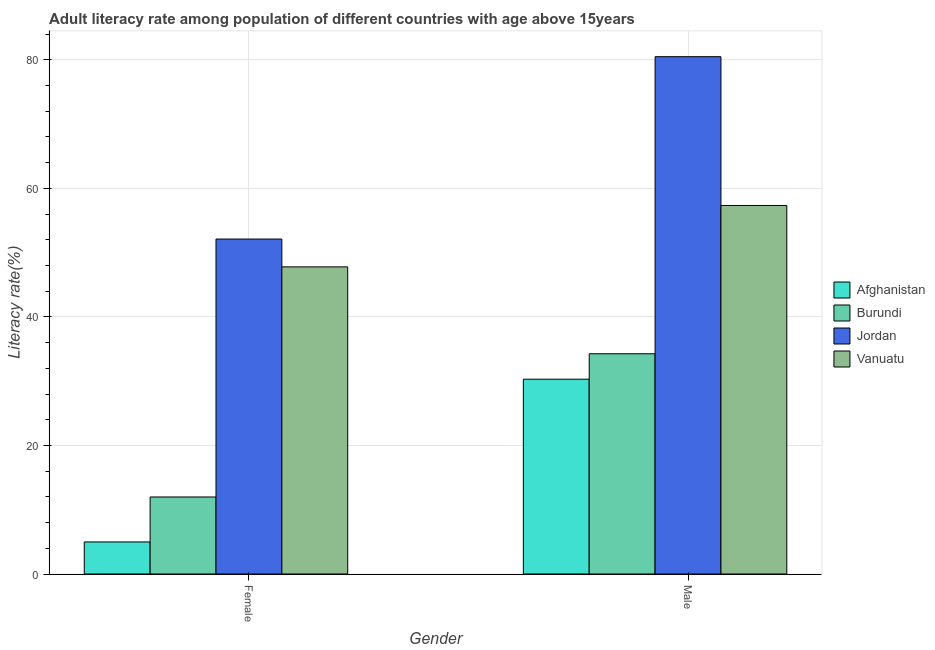How many different coloured bars are there?
Provide a short and direct response. 4. How many groups of bars are there?
Ensure brevity in your answer.  2. Are the number of bars per tick equal to the number of legend labels?
Give a very brief answer. Yes. What is the label of the 2nd group of bars from the left?
Make the answer very short. Male. What is the male adult literacy rate in Burundi?
Make the answer very short. 34.26. Across all countries, what is the maximum female adult literacy rate?
Give a very brief answer. 52.11. Across all countries, what is the minimum female adult literacy rate?
Make the answer very short. 4.99. In which country was the male adult literacy rate maximum?
Keep it short and to the point. Jordan. In which country was the female adult literacy rate minimum?
Offer a very short reply. Afghanistan. What is the total male adult literacy rate in the graph?
Make the answer very short. 202.39. What is the difference between the male adult literacy rate in Jordan and that in Afghanistan?
Provide a succinct answer. 50.17. What is the difference between the male adult literacy rate in Afghanistan and the female adult literacy rate in Vanuatu?
Make the answer very short. -17.47. What is the average male adult literacy rate per country?
Your answer should be compact. 50.6. What is the difference between the female adult literacy rate and male adult literacy rate in Afghanistan?
Provide a short and direct response. -25.32. What is the ratio of the male adult literacy rate in Jordan to that in Vanuatu?
Your response must be concise. 1.4. Is the female adult literacy rate in Jordan less than that in Afghanistan?
Give a very brief answer. No. What does the 2nd bar from the left in Female represents?
Provide a short and direct response. Burundi. What does the 1st bar from the right in Male represents?
Offer a very short reply. Vanuatu. How many bars are there?
Provide a short and direct response. 8. Are the values on the major ticks of Y-axis written in scientific E-notation?
Your answer should be very brief. No. Does the graph contain any zero values?
Provide a short and direct response. No. Does the graph contain grids?
Offer a very short reply. Yes. Where does the legend appear in the graph?
Give a very brief answer. Center right. How are the legend labels stacked?
Give a very brief answer. Vertical. What is the title of the graph?
Give a very brief answer. Adult literacy rate among population of different countries with age above 15years. What is the label or title of the X-axis?
Your response must be concise. Gender. What is the label or title of the Y-axis?
Provide a succinct answer. Literacy rate(%). What is the Literacy rate(%) in Afghanistan in Female?
Your response must be concise. 4.99. What is the Literacy rate(%) of Burundi in Female?
Your response must be concise. 11.98. What is the Literacy rate(%) in Jordan in Female?
Ensure brevity in your answer.  52.11. What is the Literacy rate(%) in Vanuatu in Female?
Your answer should be very brief. 47.78. What is the Literacy rate(%) in Afghanistan in Male?
Keep it short and to the point. 30.31. What is the Literacy rate(%) in Burundi in Male?
Provide a short and direct response. 34.26. What is the Literacy rate(%) in Jordan in Male?
Your response must be concise. 80.48. What is the Literacy rate(%) of Vanuatu in Male?
Offer a very short reply. 57.34. Across all Gender, what is the maximum Literacy rate(%) in Afghanistan?
Your response must be concise. 30.31. Across all Gender, what is the maximum Literacy rate(%) of Burundi?
Offer a very short reply. 34.26. Across all Gender, what is the maximum Literacy rate(%) in Jordan?
Ensure brevity in your answer.  80.48. Across all Gender, what is the maximum Literacy rate(%) of Vanuatu?
Give a very brief answer. 57.34. Across all Gender, what is the minimum Literacy rate(%) in Afghanistan?
Keep it short and to the point. 4.99. Across all Gender, what is the minimum Literacy rate(%) of Burundi?
Your answer should be compact. 11.98. Across all Gender, what is the minimum Literacy rate(%) of Jordan?
Ensure brevity in your answer.  52.11. Across all Gender, what is the minimum Literacy rate(%) of Vanuatu?
Your response must be concise. 47.78. What is the total Literacy rate(%) of Afghanistan in the graph?
Your answer should be compact. 35.3. What is the total Literacy rate(%) of Burundi in the graph?
Ensure brevity in your answer.  46.25. What is the total Literacy rate(%) of Jordan in the graph?
Your response must be concise. 132.59. What is the total Literacy rate(%) of Vanuatu in the graph?
Keep it short and to the point. 105.12. What is the difference between the Literacy rate(%) in Afghanistan in Female and that in Male?
Your response must be concise. -25.32. What is the difference between the Literacy rate(%) in Burundi in Female and that in Male?
Your answer should be compact. -22.28. What is the difference between the Literacy rate(%) in Jordan in Female and that in Male?
Provide a short and direct response. -28.37. What is the difference between the Literacy rate(%) in Vanuatu in Female and that in Male?
Provide a succinct answer. -9.55. What is the difference between the Literacy rate(%) of Afghanistan in Female and the Literacy rate(%) of Burundi in Male?
Provide a succinct answer. -29.28. What is the difference between the Literacy rate(%) of Afghanistan in Female and the Literacy rate(%) of Jordan in Male?
Provide a succinct answer. -75.5. What is the difference between the Literacy rate(%) in Afghanistan in Female and the Literacy rate(%) in Vanuatu in Male?
Ensure brevity in your answer.  -52.35. What is the difference between the Literacy rate(%) of Burundi in Female and the Literacy rate(%) of Jordan in Male?
Make the answer very short. -68.5. What is the difference between the Literacy rate(%) in Burundi in Female and the Literacy rate(%) in Vanuatu in Male?
Provide a short and direct response. -45.35. What is the difference between the Literacy rate(%) of Jordan in Female and the Literacy rate(%) of Vanuatu in Male?
Provide a short and direct response. -5.22. What is the average Literacy rate(%) of Afghanistan per Gender?
Your answer should be compact. 17.65. What is the average Literacy rate(%) in Burundi per Gender?
Offer a very short reply. 23.12. What is the average Literacy rate(%) of Jordan per Gender?
Offer a very short reply. 66.3. What is the average Literacy rate(%) in Vanuatu per Gender?
Give a very brief answer. 52.56. What is the difference between the Literacy rate(%) of Afghanistan and Literacy rate(%) of Burundi in Female?
Make the answer very short. -7. What is the difference between the Literacy rate(%) of Afghanistan and Literacy rate(%) of Jordan in Female?
Your response must be concise. -47.12. What is the difference between the Literacy rate(%) of Afghanistan and Literacy rate(%) of Vanuatu in Female?
Your answer should be very brief. -42.8. What is the difference between the Literacy rate(%) in Burundi and Literacy rate(%) in Jordan in Female?
Make the answer very short. -40.13. What is the difference between the Literacy rate(%) of Burundi and Literacy rate(%) of Vanuatu in Female?
Your answer should be compact. -35.8. What is the difference between the Literacy rate(%) in Jordan and Literacy rate(%) in Vanuatu in Female?
Provide a succinct answer. 4.33. What is the difference between the Literacy rate(%) of Afghanistan and Literacy rate(%) of Burundi in Male?
Ensure brevity in your answer.  -3.96. What is the difference between the Literacy rate(%) of Afghanistan and Literacy rate(%) of Jordan in Male?
Keep it short and to the point. -50.17. What is the difference between the Literacy rate(%) in Afghanistan and Literacy rate(%) in Vanuatu in Male?
Make the answer very short. -27.03. What is the difference between the Literacy rate(%) of Burundi and Literacy rate(%) of Jordan in Male?
Offer a terse response. -46.22. What is the difference between the Literacy rate(%) in Burundi and Literacy rate(%) in Vanuatu in Male?
Give a very brief answer. -23.07. What is the difference between the Literacy rate(%) in Jordan and Literacy rate(%) in Vanuatu in Male?
Your answer should be very brief. 23.15. What is the ratio of the Literacy rate(%) in Afghanistan in Female to that in Male?
Your response must be concise. 0.16. What is the ratio of the Literacy rate(%) in Burundi in Female to that in Male?
Keep it short and to the point. 0.35. What is the ratio of the Literacy rate(%) of Jordan in Female to that in Male?
Give a very brief answer. 0.65. What is the ratio of the Literacy rate(%) in Vanuatu in Female to that in Male?
Your answer should be very brief. 0.83. What is the difference between the highest and the second highest Literacy rate(%) in Afghanistan?
Provide a succinct answer. 25.32. What is the difference between the highest and the second highest Literacy rate(%) in Burundi?
Ensure brevity in your answer.  22.28. What is the difference between the highest and the second highest Literacy rate(%) of Jordan?
Your answer should be compact. 28.37. What is the difference between the highest and the second highest Literacy rate(%) of Vanuatu?
Keep it short and to the point. 9.55. What is the difference between the highest and the lowest Literacy rate(%) in Afghanistan?
Your answer should be very brief. 25.32. What is the difference between the highest and the lowest Literacy rate(%) of Burundi?
Make the answer very short. 22.28. What is the difference between the highest and the lowest Literacy rate(%) in Jordan?
Your response must be concise. 28.37. What is the difference between the highest and the lowest Literacy rate(%) of Vanuatu?
Provide a succinct answer. 9.55. 